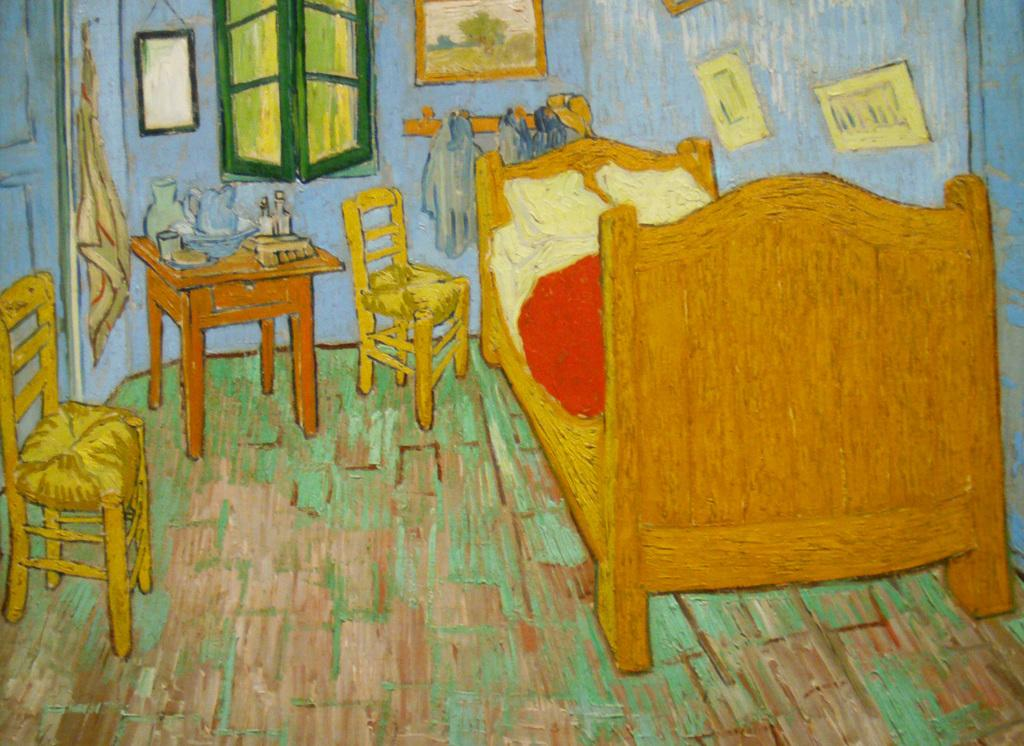What type of artwork is depicted in the image? The image is a painting. What type of furniture can be seen in the painting? There is a bed, chairs, and a tablecloth in the image. What architectural features are present in the painting? There is a window, a door, and a wall in the image. What is at the bottom of the painting? There is a floor at the bottom of the image. What decorative items are present in the painting? There are photo frames in the image. Can you see a hose being used in the painting? No, there is no hose present in the painting. 